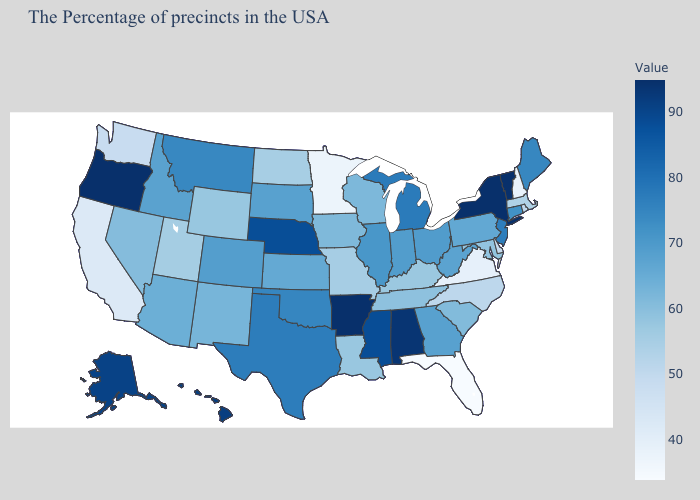Which states hav the highest value in the West?
Be succinct. Oregon. Among the states that border Iowa , which have the highest value?
Be succinct. Nebraska. Which states have the highest value in the USA?
Answer briefly. Vermont, New York, Arkansas, Oregon. Does Florida have the lowest value in the USA?
Keep it brief. Yes. Among the states that border Mississippi , which have the highest value?
Answer briefly. Arkansas. Does Wisconsin have the lowest value in the USA?
Quick response, please. No. Among the states that border Nevada , which have the lowest value?
Keep it brief. California. 